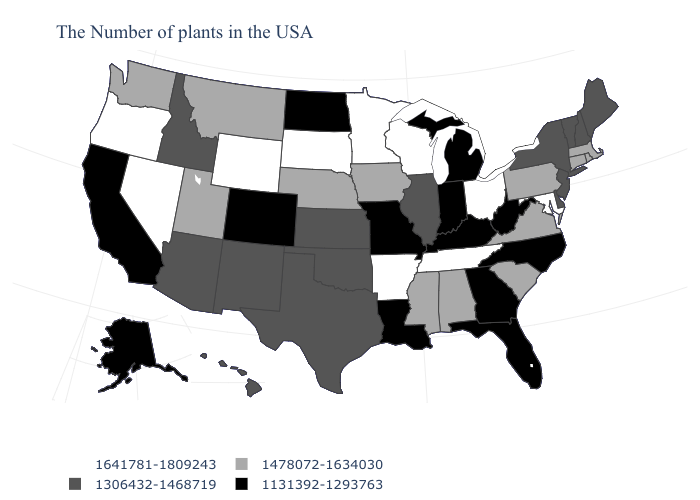Which states hav the highest value in the West?
Concise answer only. Wyoming, Nevada, Oregon. What is the value of New York?
Give a very brief answer. 1306432-1468719. Does Delaware have a lower value than Missouri?
Concise answer only. No. Name the states that have a value in the range 1306432-1468719?
Quick response, please. Maine, New Hampshire, Vermont, New York, New Jersey, Delaware, Illinois, Kansas, Oklahoma, Texas, New Mexico, Arizona, Idaho, Hawaii. What is the value of Arkansas?
Keep it brief. 1641781-1809243. Does Pennsylvania have the lowest value in the Northeast?
Write a very short answer. No. Name the states that have a value in the range 1131392-1293763?
Give a very brief answer. North Carolina, West Virginia, Florida, Georgia, Michigan, Kentucky, Indiana, Louisiana, Missouri, North Dakota, Colorado, California, Alaska. Among the states that border Nebraska , which have the lowest value?
Concise answer only. Missouri, Colorado. Does Kansas have the highest value in the MidWest?
Give a very brief answer. No. What is the value of Oklahoma?
Answer briefly. 1306432-1468719. Among the states that border Indiana , does Michigan have the lowest value?
Concise answer only. Yes. Name the states that have a value in the range 1641781-1809243?
Write a very short answer. Maryland, Ohio, Tennessee, Wisconsin, Arkansas, Minnesota, South Dakota, Wyoming, Nevada, Oregon. Which states have the highest value in the USA?
Answer briefly. Maryland, Ohio, Tennessee, Wisconsin, Arkansas, Minnesota, South Dakota, Wyoming, Nevada, Oregon. What is the value of Iowa?
Write a very short answer. 1478072-1634030. What is the value of Alabama?
Keep it brief. 1478072-1634030. 